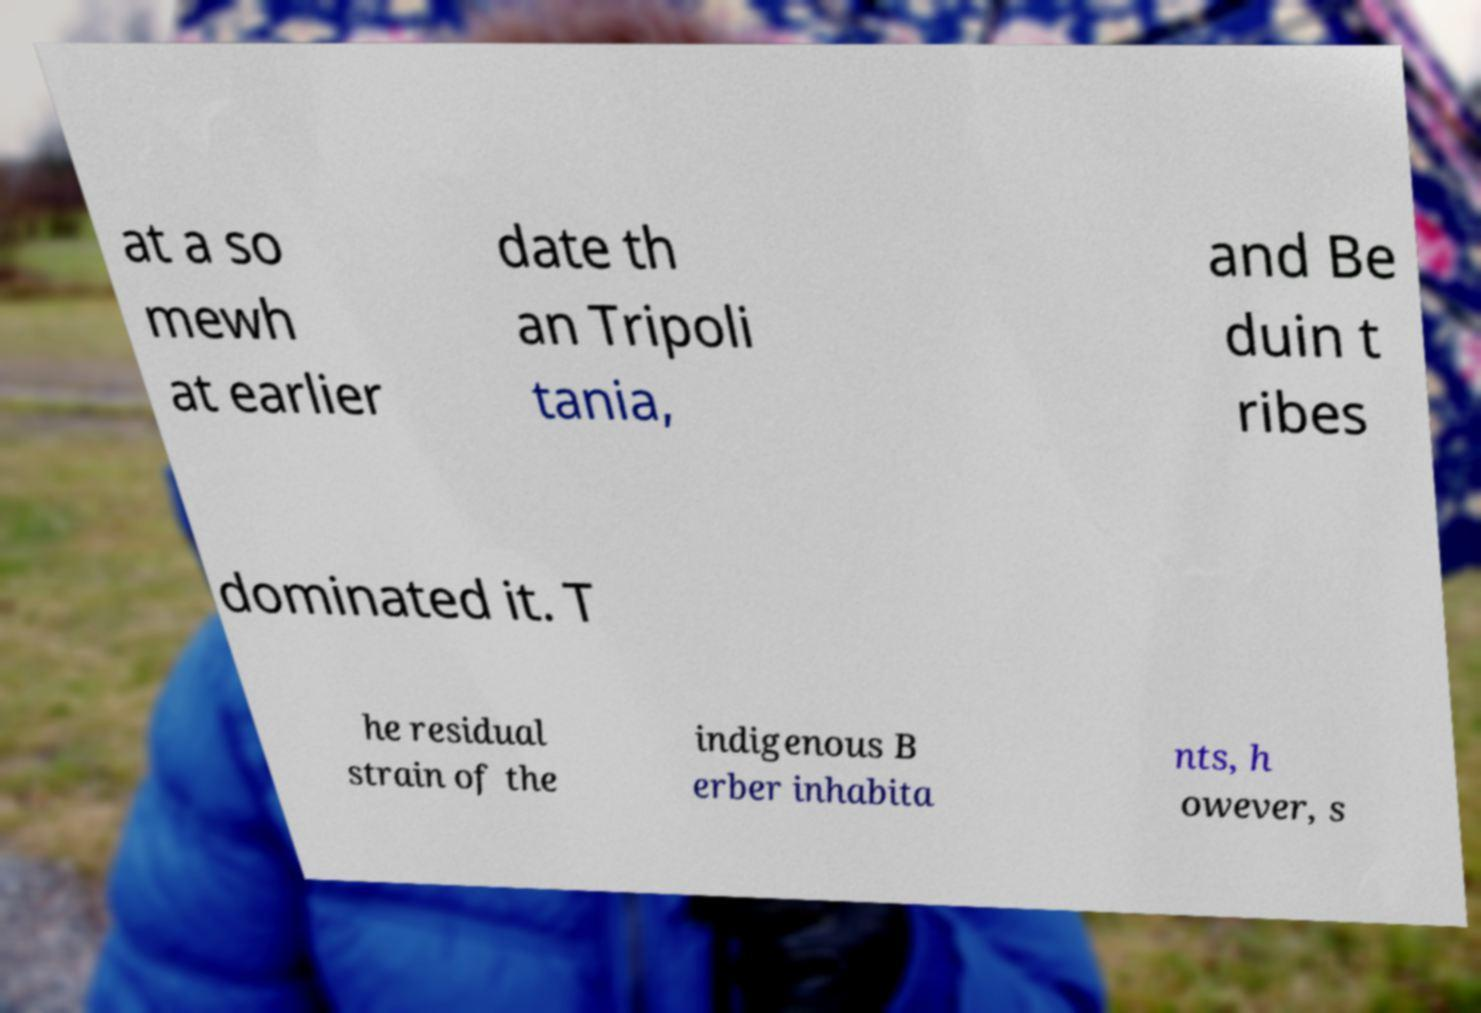Can you read and provide the text displayed in the image?This photo seems to have some interesting text. Can you extract and type it out for me? at a so mewh at earlier date th an Tripoli tania, and Be duin t ribes dominated it. T he residual strain of the indigenous B erber inhabita nts, h owever, s 